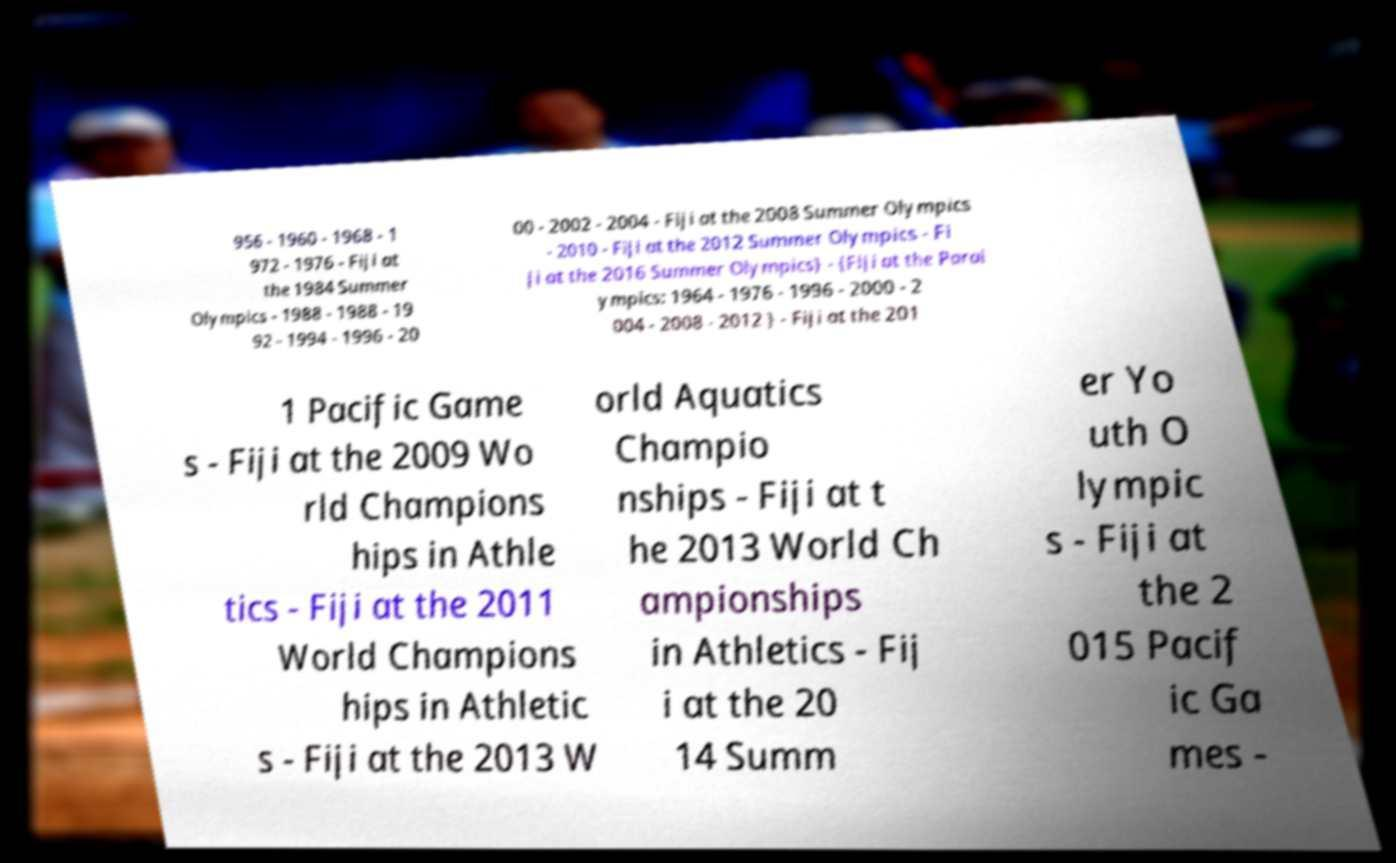I need the written content from this picture converted into text. Can you do that? 956 - 1960 - 1968 - 1 972 - 1976 - Fiji at the 1984 Summer Olympics - 1988 - 1988 - 19 92 - 1994 - 1996 - 20 00 - 2002 - 2004 - Fiji at the 2008 Summer Olympics - 2010 - Fiji at the 2012 Summer Olympics - Fi ji at the 2016 Summer Olympics} - {Fiji at the Paral ympics: 1964 - 1976 - 1996 - 2000 - 2 004 - 2008 - 2012 } - Fiji at the 201 1 Pacific Game s - Fiji at the 2009 Wo rld Champions hips in Athle tics - Fiji at the 2011 World Champions hips in Athletic s - Fiji at the 2013 W orld Aquatics Champio nships - Fiji at t he 2013 World Ch ampionships in Athletics - Fij i at the 20 14 Summ er Yo uth O lympic s - Fiji at the 2 015 Pacif ic Ga mes - 